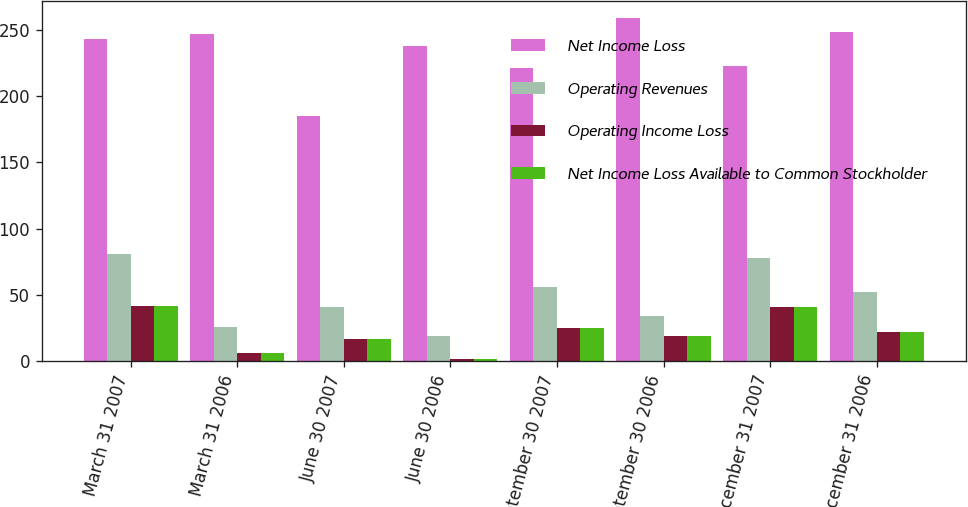Convert chart. <chart><loc_0><loc_0><loc_500><loc_500><stacked_bar_chart><ecel><fcel>March 31 2007<fcel>March 31 2006<fcel>June 30 2007<fcel>June 30 2006<fcel>September 30 2007<fcel>September 30 2006<fcel>December 31 2007<fcel>December 31 2006<nl><fcel>Net Income Loss<fcel>243<fcel>247<fcel>185<fcel>238<fcel>221<fcel>259<fcel>223<fcel>248<nl><fcel>Operating Revenues<fcel>81<fcel>26<fcel>41<fcel>19<fcel>56<fcel>34<fcel>78<fcel>52<nl><fcel>Operating Income Loss<fcel>42<fcel>6<fcel>17<fcel>2<fcel>25<fcel>19<fcel>41<fcel>22<nl><fcel>Net Income Loss Available to Common Stockholder<fcel>42<fcel>6<fcel>17<fcel>2<fcel>25<fcel>19<fcel>41<fcel>22<nl></chart> 